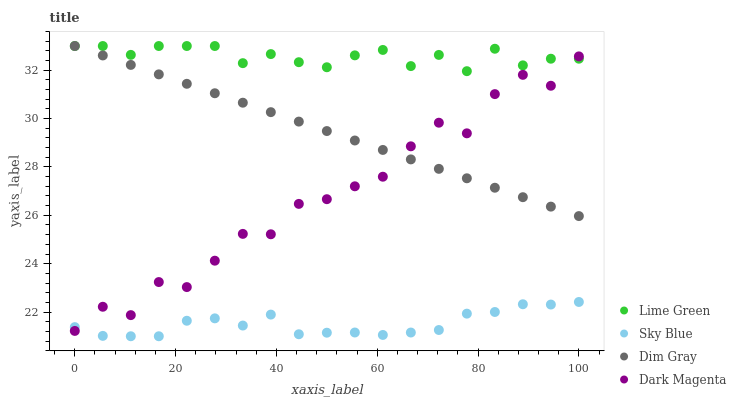Does Sky Blue have the minimum area under the curve?
Answer yes or no. Yes. Does Lime Green have the maximum area under the curve?
Answer yes or no. Yes. Does Dim Gray have the minimum area under the curve?
Answer yes or no. No. Does Dim Gray have the maximum area under the curve?
Answer yes or no. No. Is Dim Gray the smoothest?
Answer yes or no. Yes. Is Dark Magenta the roughest?
Answer yes or no. Yes. Is Lime Green the smoothest?
Answer yes or no. No. Is Lime Green the roughest?
Answer yes or no. No. Does Sky Blue have the lowest value?
Answer yes or no. Yes. Does Dim Gray have the lowest value?
Answer yes or no. No. Does Lime Green have the highest value?
Answer yes or no. Yes. Does Dark Magenta have the highest value?
Answer yes or no. No. Is Sky Blue less than Dim Gray?
Answer yes or no. Yes. Is Lime Green greater than Sky Blue?
Answer yes or no. Yes. Does Dim Gray intersect Lime Green?
Answer yes or no. Yes. Is Dim Gray less than Lime Green?
Answer yes or no. No. Is Dim Gray greater than Lime Green?
Answer yes or no. No. Does Sky Blue intersect Dim Gray?
Answer yes or no. No. 